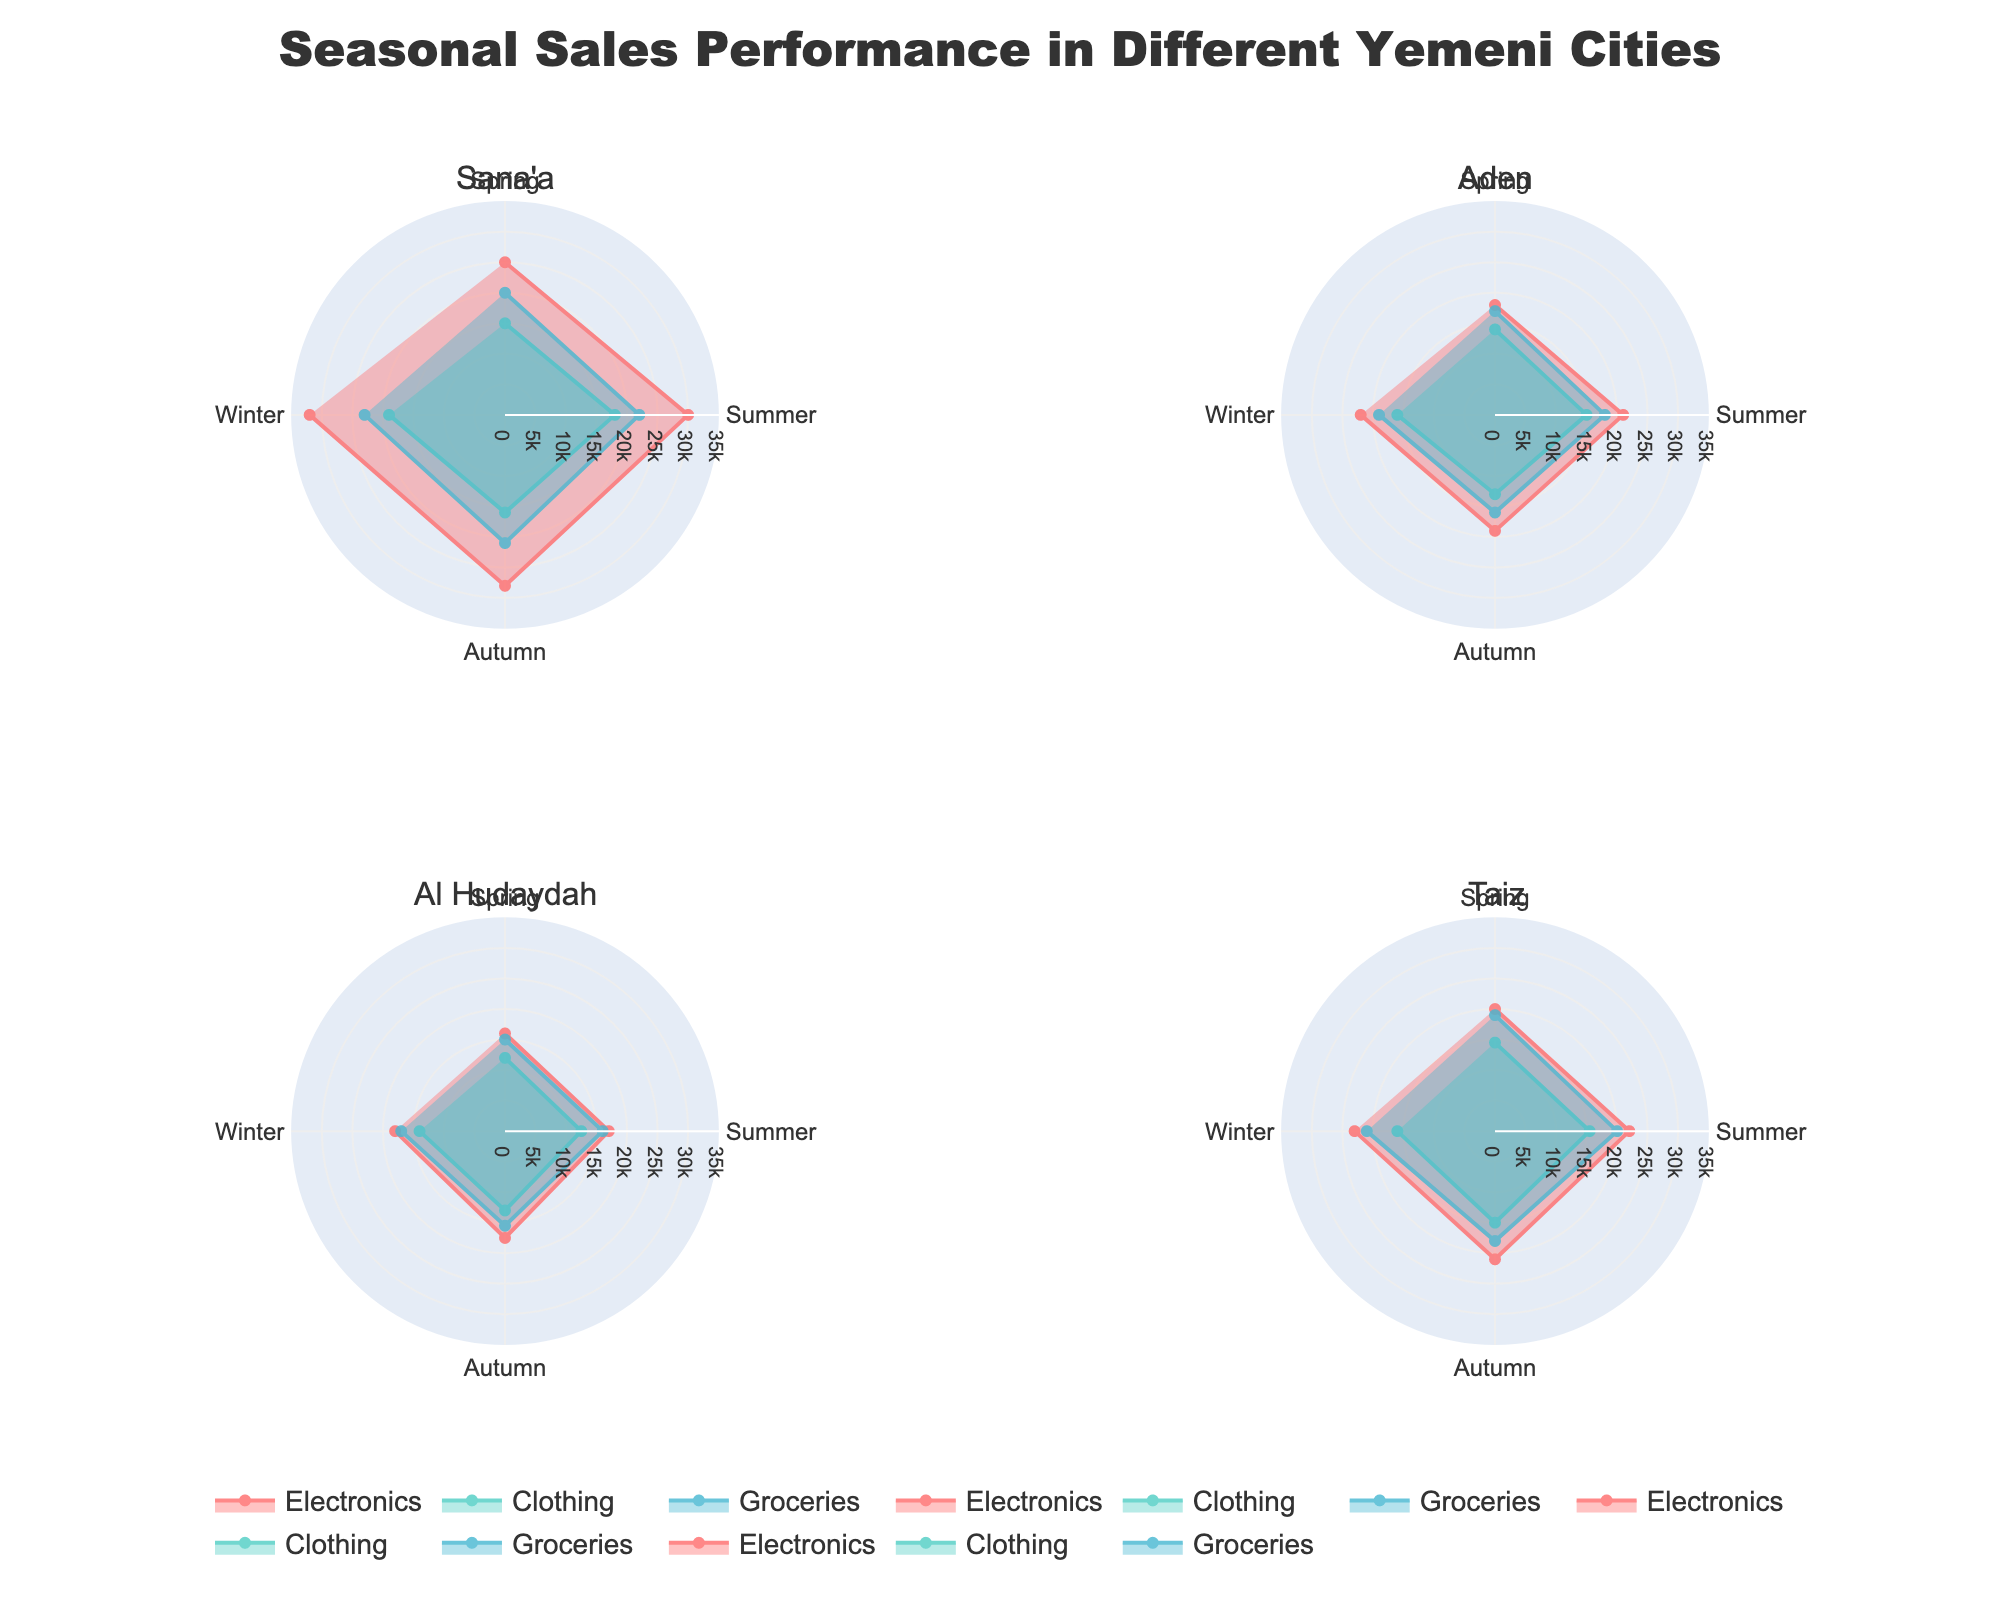What is the title of the figure? The title of the figure is prominently displayed at the top of the plot.
Answer: Seasonal Sales Performance in Different Yemeni Cities During which season did Sana'a have the highest sales in Electronics? Look for the largest radius in the Electronics category for Sana'a across all seasons. In the spring, summer, autumn, and winter, the respective sales for Electronics are 25,000, 30,000, 28,000, and 32,000.
Answer: Winter Which city had the lowest total sales for Groceries in Summer? Sum the summer grocery sales for each city and compare. (Sana'a: 22,000, Aden: 18,000, Al Hudaydah: 16,000, Taiz: 20,000)
Answer: Al Hudaydah What color represents Clothing in the plot? Examine the color assigned to the Clothing category in the legend.
Answer: Teal How do the Spring sales for Electronics compare between Taiz and Al Hudaydah? Check the spring sales for Electronics in the Taiz and Al Hudaydah plots. Taiz has sales of 20,000, whereas Al Hudaydah has 16,000.
Answer: Taiz has higher sales In which season did Al Hudaydah see the highest sales for Clothing? Check for the season with the largest radius in the Clothing category for Al Hudaydah. Spring (12,000), Summer (12,500), Autumn (13,000), Winter (14,000).
Answer: Winter Which category had the highest variability in sales in Aden? Compute the range (difference between the maximum and minimum) of sales for each category. Electronics (22,000-18,000), Clothing (16,000-13,000), Groceries (19,000-16,000). Compare the ranges.
Answer: Electronics What is the average sales for Groceries in Sana'a during Autumn and Winter? Add the sales for groceries in these seasons and divide by 2. (Autumn: 21,000, Winter: 23,000). (21,000 + 23,000) / 2 = 22,000.
Answer: 22,000 Which city has the smallest difference in Electronics sales between Summer and Winter? Calculate the differences for each city. Sana'a (32,000-30,000=2,000), Aden (22,000-21,000=1,000), Al Hudaydah (18,000-17,000=1,000), Taiz (23,000-22,000=1,000). All cities except Sana'a have the same smallest difference.
Answer: Aden, Al Hudaydah, and Taiz 